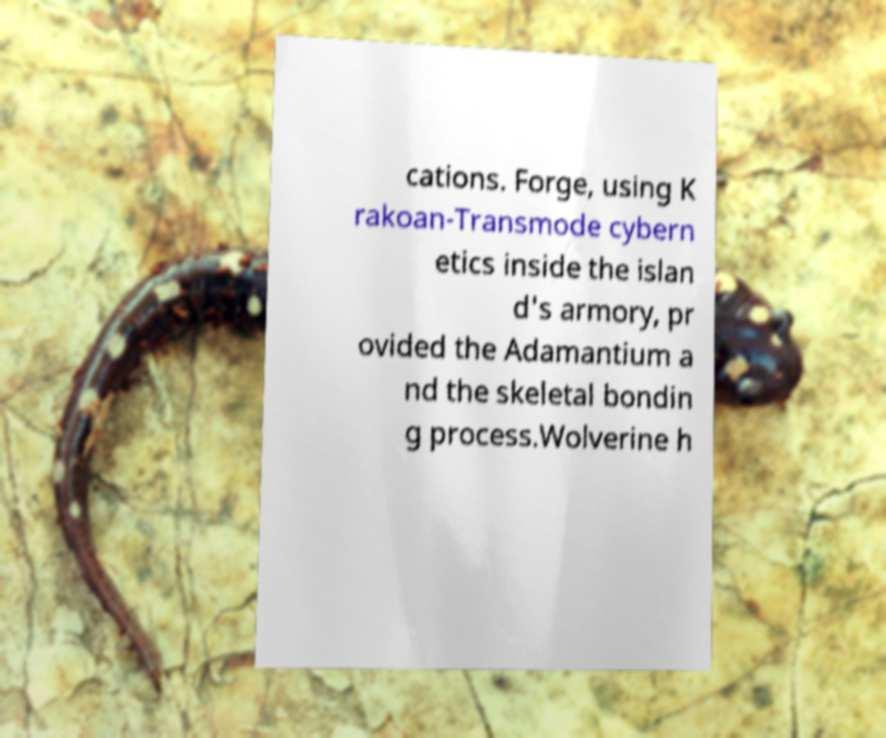Could you extract and type out the text from this image? cations. Forge, using K rakoan-Transmode cybern etics inside the islan d's armory, pr ovided the Adamantium a nd the skeletal bondin g process.Wolverine h 